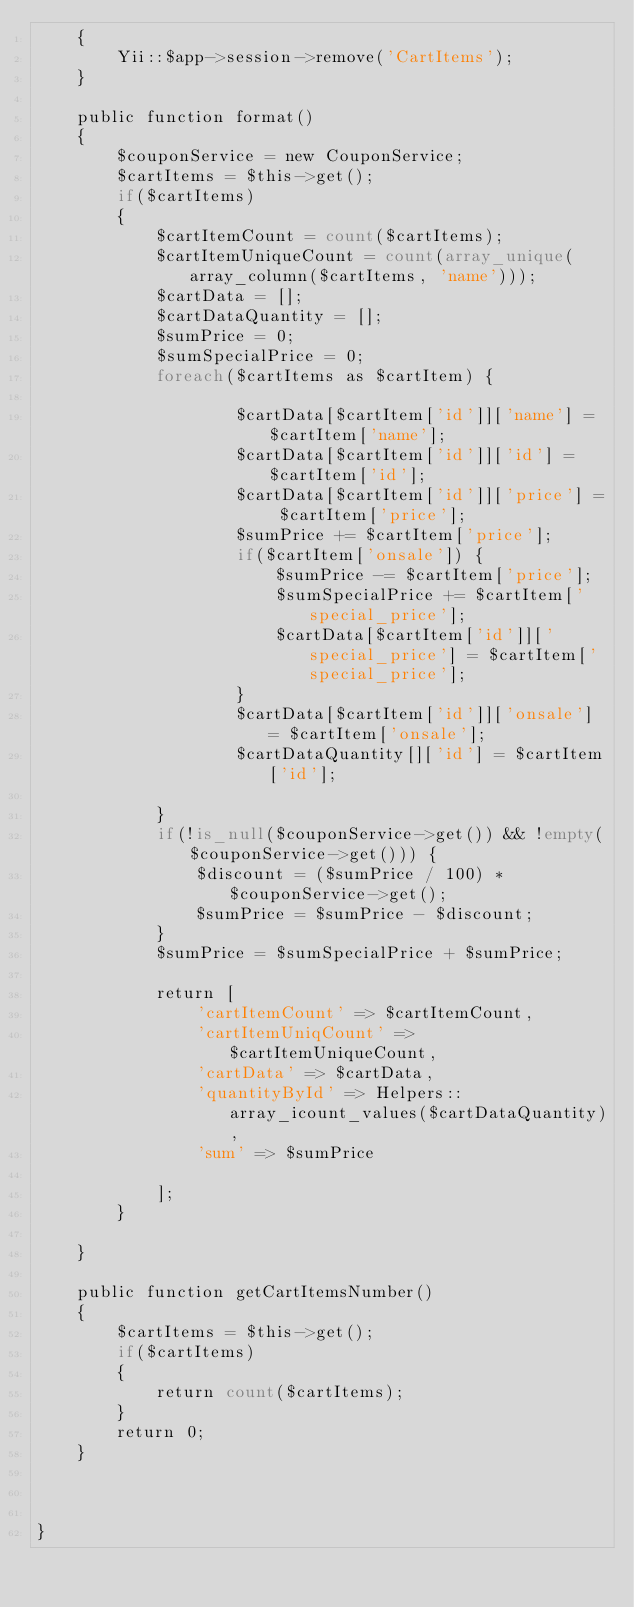<code> <loc_0><loc_0><loc_500><loc_500><_PHP_>    {
        Yii::$app->session->remove('CartItems');
    }

    public function format()
    {
        $couponService = new CouponService;
        $cartItems = $this->get();
        if($cartItems) 
        {
            $cartItemCount = count($cartItems);
            $cartItemUniqueCount = count(array_unique(array_column($cartItems, 'name'))); 
            $cartData = [];
            $cartDataQuantity = []; 
            $sumPrice = 0;
            $sumSpecialPrice = 0;
            foreach($cartItems as $cartItem) {
                
                    $cartData[$cartItem['id']]['name'] = $cartItem['name'];
                    $cartData[$cartItem['id']]['id'] = $cartItem['id'];
                    $cartData[$cartItem['id']]['price'] = $cartItem['price'];
                    $sumPrice += $cartItem['price'];
                    if($cartItem['onsale']) {
                        $sumPrice -= $cartItem['price'];
                        $sumSpecialPrice += $cartItem['special_price'];
                        $cartData[$cartItem['id']]['special_price'] = $cartItem['special_price'];
                    }
                    $cartData[$cartItem['id']]['onsale'] = $cartItem['onsale'];
                    $cartDataQuantity[]['id'] = $cartItem['id'];             
                
            }
            if(!is_null($couponService->get()) && !empty($couponService->get())) {
                $discount = ($sumPrice / 100) * $couponService->get();
                $sumPrice = $sumPrice - $discount;
            }
            $sumPrice = $sumSpecialPrice + $sumPrice;
           
            return [
                'cartItemCount' => $cartItemCount,
                'cartItemUniqCount' => $cartItemUniqueCount,
                'cartData' => $cartData,
                'quantityById' => Helpers::array_icount_values($cartDataQuantity),
                'sum' => $sumPrice
    
            ];
        }
      
    }

    public function getCartItemsNumber()
    {
        $cartItems = $this->get();
        if($cartItems) 
        {
            return count($cartItems);
        }
        return 0;
    }


    
}</code> 